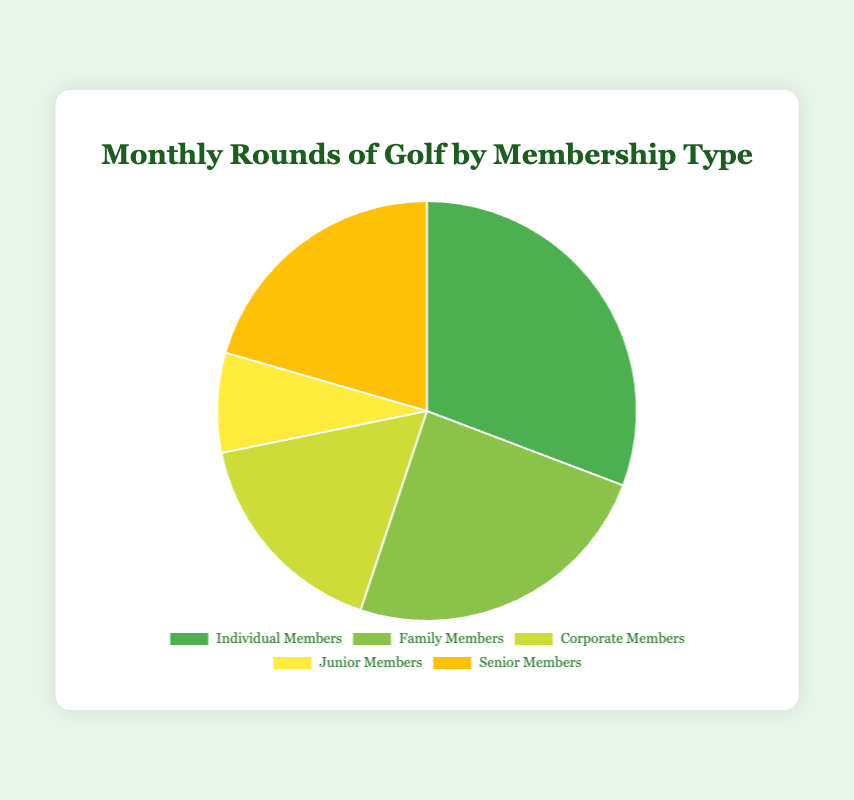Which membership type played the most rounds? By looking at the size of the slices, the "Individual Members" slice is the largest, indicating they played the most rounds.
Answer: Individual Members What's the sum of rounds played by Junior Members and Senior Members? Junior Members played 300 rounds, and Senior Members played 800 rounds. Adding these two values gives 300 + 800 = 1100.
Answer: 1100 Which membership type has the smallest slice in the pie chart? "Junior Members" slice is the smallest in the pie chart.
Answer: Junior Members How many more rounds did Individual Members play than Corporate Members? Individual Members played 1200 rounds, while Corporate Members played 650 rounds. The difference is 1200 - 650 = 550.
Answer: 550 What percentage of the total rounds did Family Members play? The total rounds played is 1200 + 950 + 650 + 300 + 800 = 3900. Family Members played 950 rounds. The percentage is (950 / 3900) × 100 ≈ 24.36%.
Answer: ~24.36% Which membership types played a combined total of 1850 rounds? By checking combinations, Individual Members (1200 rounds) and Senior Members (800 rounds) together played 1200 + 800 = 2000 rounds, Family Members (950 rounds) and Corporate Members (650 rounds) played 950 + 650 = 1600, but Individual Members (1200 rounds) and Family Members (950 rounds) together played 1200 + 950 = 2150. So, no combination sums to 1850 exactly, but the closest groups are Individual and Family Members at 2150 rounds.
Answer: No exact match (closest: Individual and Family Members at 2150) What is the difference in the number of rounds played between the largest and the smallest membership groups? The largest group is Individual Members with 1200 rounds, and the smallest is Junior Members with 300 rounds. The difference is 1200 - 300 = 900 rounds.
Answer: 900 If Family Members and Corporate Members combined to form a new group, how many rounds would this new group have played? Family Members played 950 rounds and Corporate Members played 650 rounds. Combined, they would have played 950 + 650 = 1600 rounds.
Answer: 1600 Which color represents the Junior Members? The slice for Junior Members is represented by the color yellow.
Answer: Yellow Rank the membership types by the number of rounds played, from highest to lowest. By comparing the sizes of the slices: 1. Individual Members (1200 rounds), 2. Family Members (950 rounds), 3. Senior Members (800 rounds), 4. Corporate Members (650 rounds), 5. Junior Members (300 rounds).
Answer: Individual, Family, Senior, Corporate, Junior 